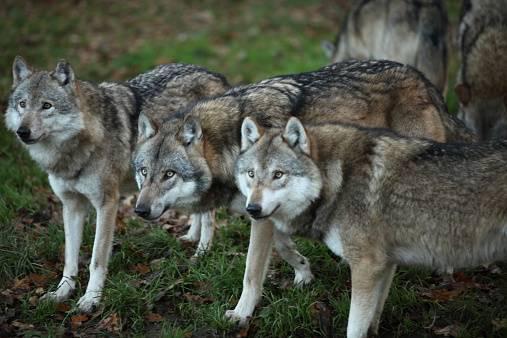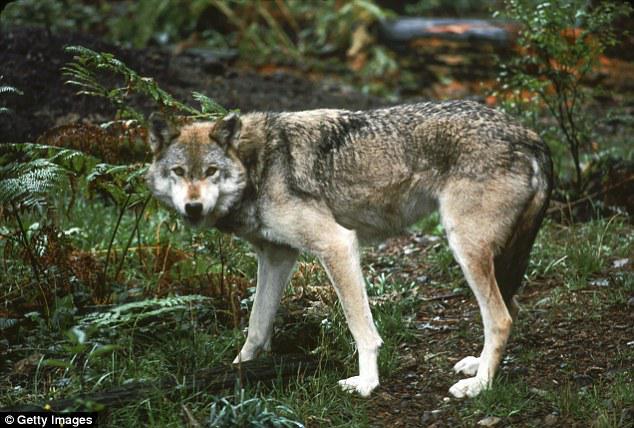The first image is the image on the left, the second image is the image on the right. Given the left and right images, does the statement "In the right image there are three adult wolves." hold true? Answer yes or no. No. The first image is the image on the left, the second image is the image on the right. Given the left and right images, does the statement "One image contains four wolves, several of which are perched on large grey rocks, and several facing rightward with heads high." hold true? Answer yes or no. No. 